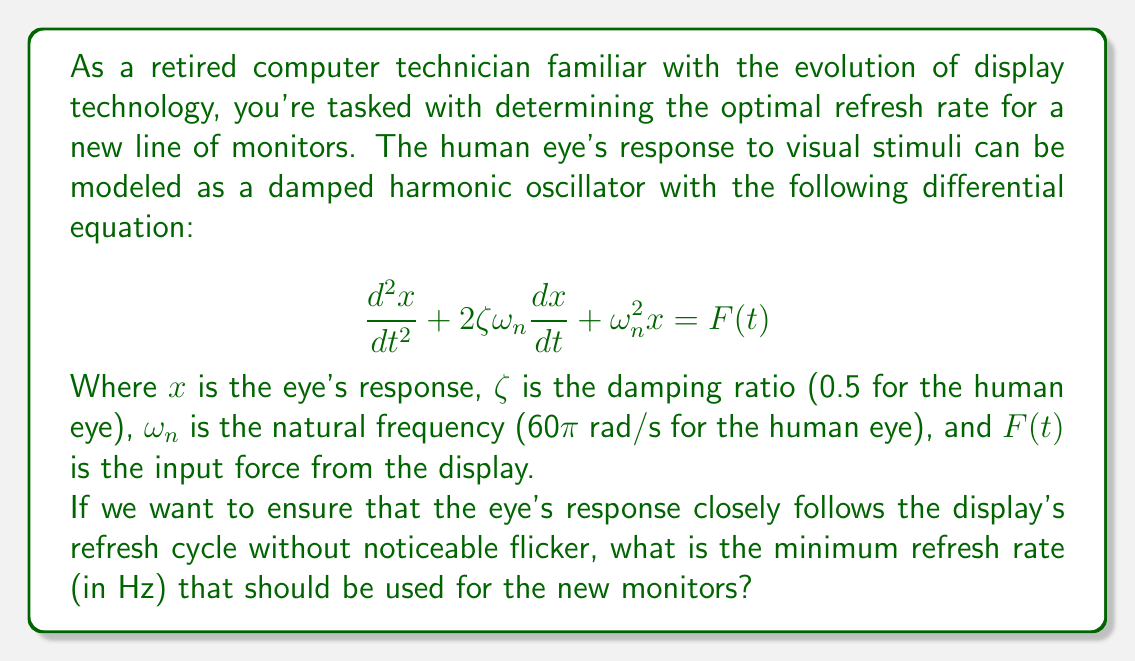Solve this math problem. To solve this problem, we need to understand the relationship between the natural frequency of the human eye and the optimal refresh rate for displays. Let's break it down step-by-step:

1) The natural frequency of the human eye is given as $\omega_n = 60\pi$ rad/s.

2) To convert this to Hz, we use the formula:
   $$f_n = \frac{\omega_n}{2\pi}$$
   
   $$f_n = \frac{60\pi}{2\pi} = 30 \text{ Hz}$$

3) This means that the human eye naturally oscillates at about 30 Hz.

4) To avoid noticeable flicker, we need the refresh rate to be faster than the eye can detect. A general rule in signal processing is that the sampling rate (in this case, the refresh rate) should be at least twice the highest frequency component of the signal (known as the Nyquist rate).

5) Therefore, the minimum refresh rate should be:
   $$f_{refresh} = 2 * f_n = 2 * 30 = 60 \text{ Hz}$$

6) However, to ensure a smooth experience and account for individual variations, it's common practice to use a slightly higher rate. Many modern displays use 75 Hz, 120 Hz, or even higher.

7) Given your background in computer technology, you might recall that early CRT monitors often used 60 Hz, which could cause eye strain for some users. The trend has been towards higher refresh rates for improved visual comfort and reduced flicker.

Therefore, while 60 Hz is the theoretical minimum, a more practical minimum for optimal viewing experience would be 75 Hz.
Answer: The minimum optimal refresh rate for the new monitors should be 75 Hz. 